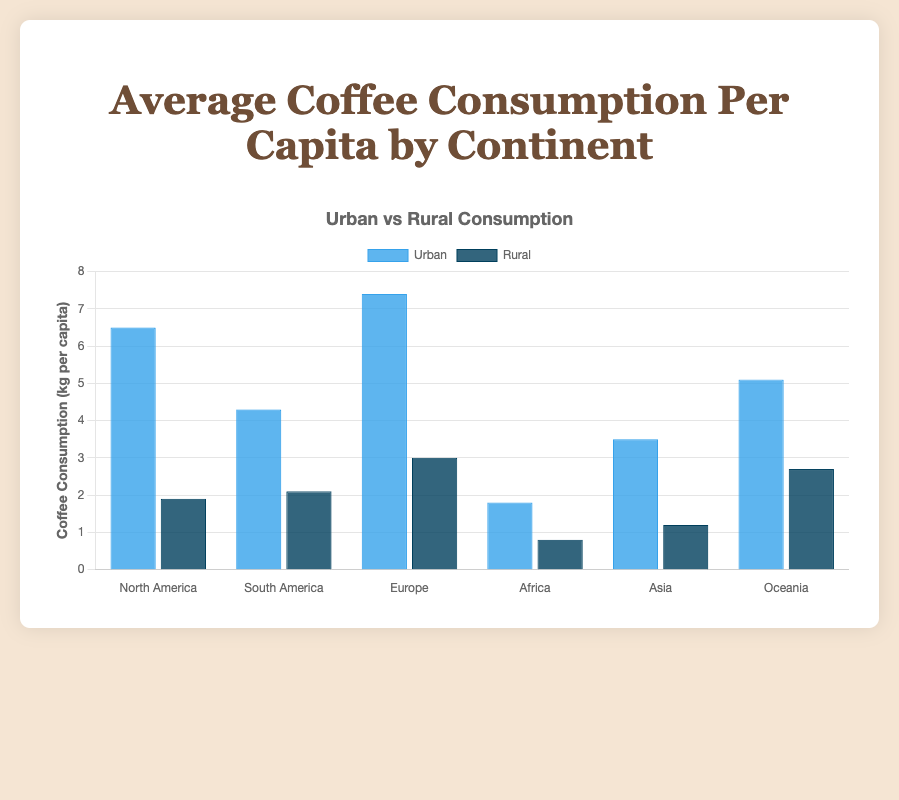Which continent has the highest urban coffee consumption? By looking at the highest bars in the 'Urban' group, Europe has the highest bar reaching 7.4 kg per capita.
Answer: Europe Which continent has the smallest difference in coffee consumption between urban and rural areas? The differences are calculated as follows: North America (4.6), South America (2.2), Europe (4.4), Africa (1.0), Asia (2.3), Oceania (2.4). Africa has the smallest difference.
Answer: Africa What is the total coffee consumption per capita for urban and rural areas in North America? Adding urban (6.5) and rural (1.9) for North America results in 6.5 + 1.9 = 8.4 kg per capita.
Answer: 8.4 kg Which continent shows a nearly equal level of consumption patterns in urban and rural areas? Comparing the bars, South America has a relatively close range with urban at 4.3 and rural at 2.1 kg per capita.
Answer: South America What is the average rural coffee consumption across all continents? Adding up rural values: 1.9 + 2.1 + 3.0 + 0.8 + 1.2 + 2.7, and dividing by 6 gives (1.9 + 2.1 + 3.0 + 0.8 + 1.2 + 2.7) / 6 = 1.95 kg per capita.
Answer: 1.95 kg By how much does the urban coffee consumption in Europe exceed that in Asia? Subtracting Asia's urban consumption (3.5) from Europe's (7.4) gives 7.4 - 3.5 = 3.9 kg per capita.
Answer: 3.9 kg On average, which continent has a higher coffee consumption in rural areas: Oceania or South America? Comparing the rural values: Oceania (2.7) vs. South America (2.1), Oceania has the higher value.
Answer: Oceania Which continents have more coffee consumption in rural areas than Africa's urban consumption? Africa's urban consumption is 1.8 kg per capita. Comparing this value, Europe (3.0), Oceania (2.7) have rural consumption higher than 1.8 kg per capita.
Answer: Europe, Oceania What is the combined average coffee consumption per capita for both urban and rural areas in Asia and Oceania? First, sum the values for both regions: Asia (urban: 3.5, rural: 1.2) and Oceania (urban: 5.1, rural: 2.7). Averages are (3.5 + 1.2 = 4.7; 5.1 + 2.7 = 7.8). Combined average (4.7 + 7.8) / 2 = 6.25 kg per capita.
Answer: 6.25 kg 